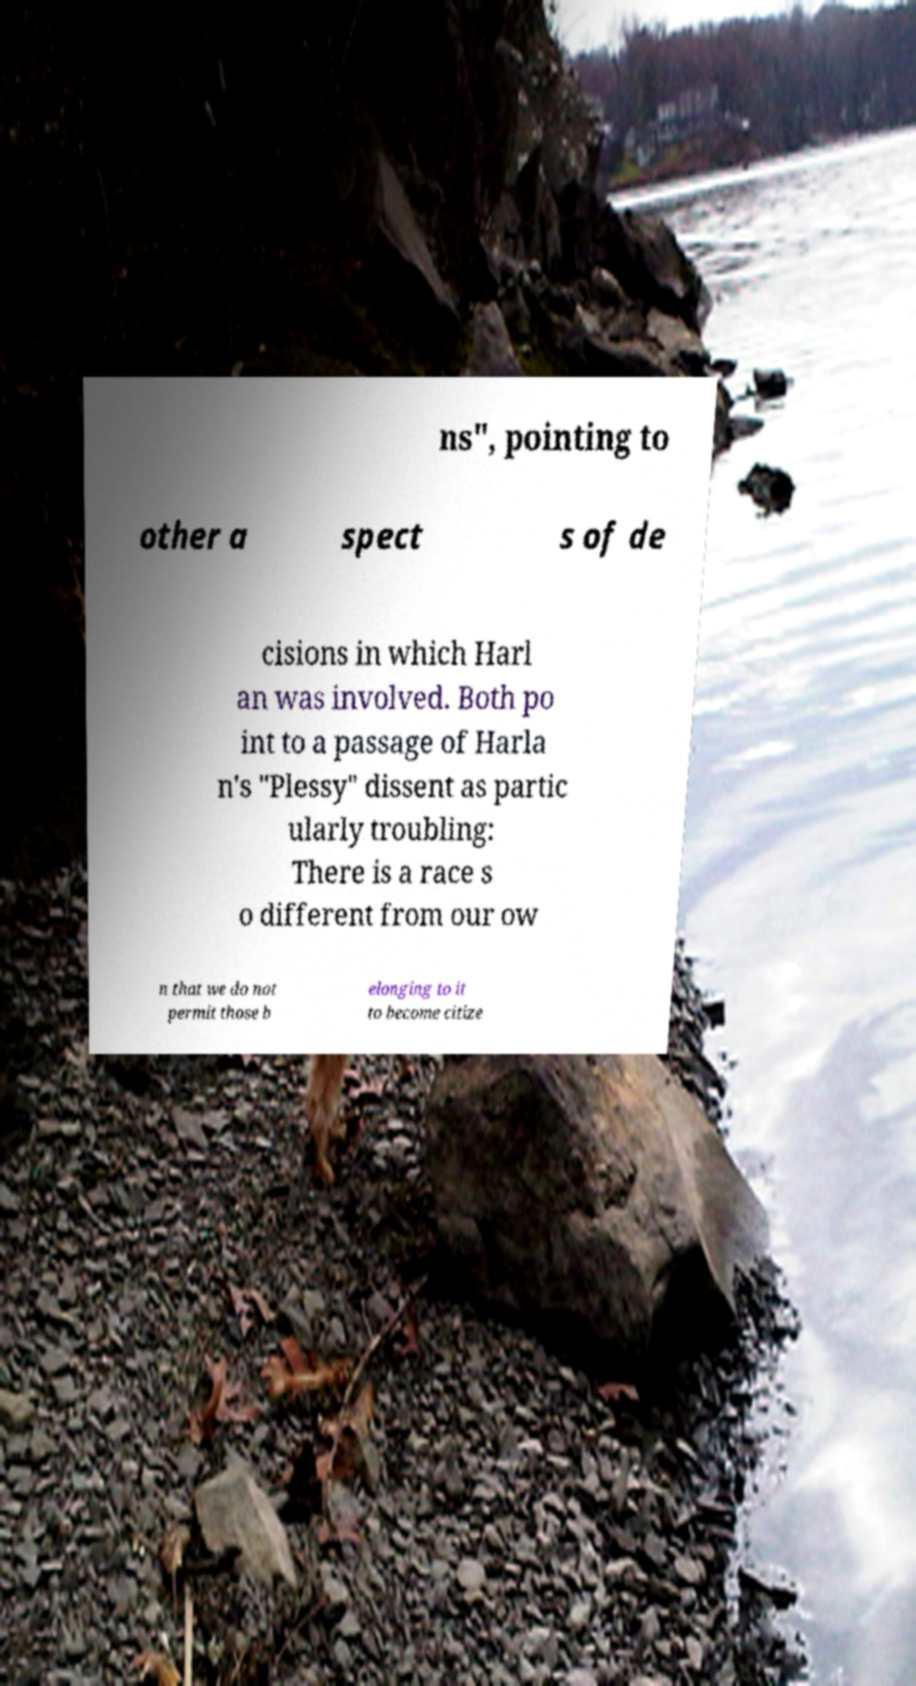Please read and relay the text visible in this image. What does it say? ns", pointing to other a spect s of de cisions in which Harl an was involved. Both po int to a passage of Harla n's "Plessy" dissent as partic ularly troubling: There is a race s o different from our ow n that we do not permit those b elonging to it to become citize 